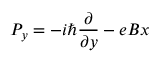Convert formula to latex. <formula><loc_0><loc_0><loc_500><loc_500>P _ { y } = - i \hbar { } \partial } { \partial y } - e B x</formula> 